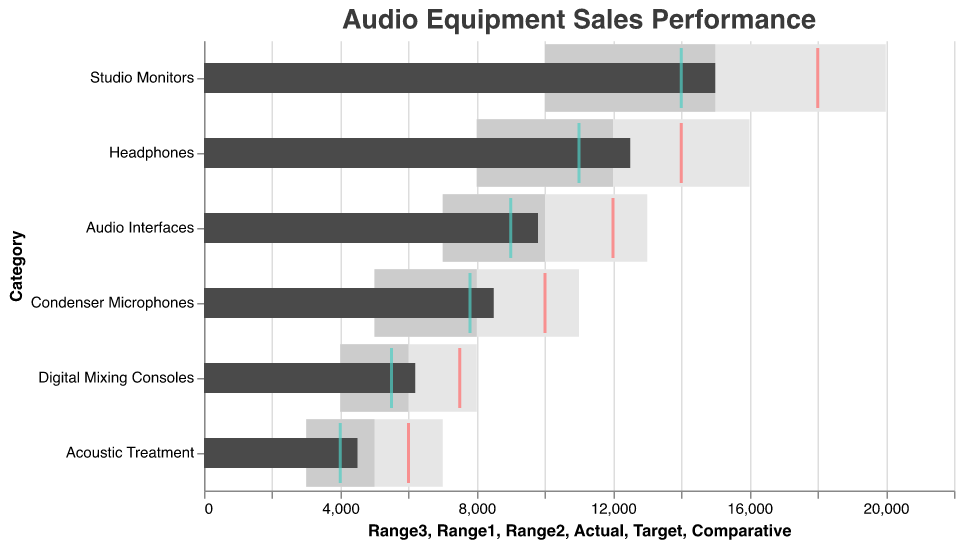What is the actual sales value for Studio Monitors? The actual sales value is represented by the dark bar. For Studio Monitors, the dark bar reaches the value of 15000.
Answer: 15000 How does the actual sales of Digital Mixing Consoles compare to the target? The actual sales value for Digital Mixing Consoles is 6200, while the target value is represented by the red tick mark at 7500. Actual sales are below the target.
Answer: Below Target What is the category with the highest target sales value? The target sales value is represented by the red tick marks. Studio Monitors have the highest target value at 18000.
Answer: Studio Monitors Which category has the smallest difference between the actual and comparative values? The actual and comparative values can be compared for each category: Studio Monitors (1000), Condenser Microphones (700), Digital Mixing Consoles (700), Audio Interfaces (800), Headphones (1500), Acoustic Treatment (500). Acoustic Treatment has the smallest difference of 500.
Answer: Acoustic Treatment For which category is the actual sales the farthest from reaching the target? Compute the difference between the actual and the target values for each category: Studio Monitors (3000), Condenser Microphones (1500), Digital Mixing Consoles (1300), Audio Interfaces (2200), Headphones (1500), Acoustic Treatment (1500). Studio Monitors have the largest gap, with actual sales being 3000 units away from the target.
Answer: Studio Monitors What is the range of sales that falls within the second performance threshold for Headphones? The second performance threshold range is indicated by the lighter gray bar for each category. For Headphones, this range is from 8000 to 12000.
Answer: 8000 to 12000 Which product category shows the comparative value falling outside the best range (Range3)? For each category, compare the comparative value with Range3 (darkest gray bar). The comparative value for Digital Mixing Consoles (5500) is the only one falling outside the best range (4000 to 8000), as it is below 6000.
Answer: Digital Mixing Consoles 